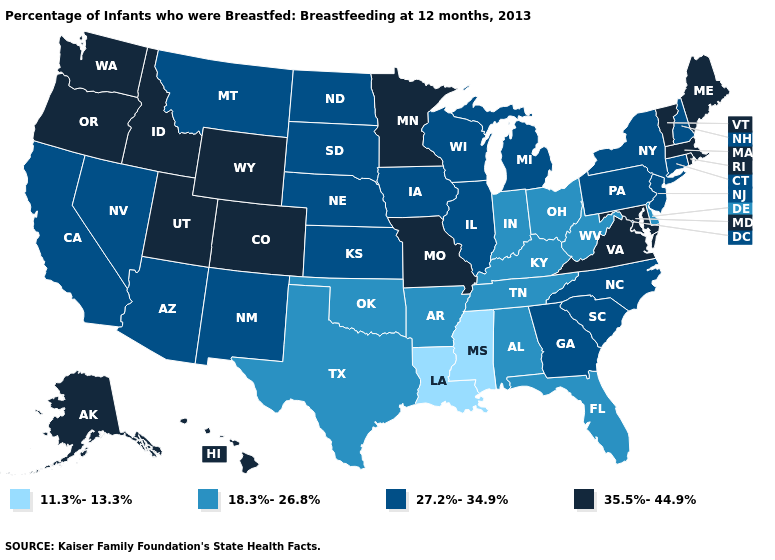What is the lowest value in the West?
Give a very brief answer. 27.2%-34.9%. Name the states that have a value in the range 35.5%-44.9%?
Quick response, please. Alaska, Colorado, Hawaii, Idaho, Maine, Maryland, Massachusetts, Minnesota, Missouri, Oregon, Rhode Island, Utah, Vermont, Virginia, Washington, Wyoming. Does Wisconsin have the lowest value in the MidWest?
Write a very short answer. No. Does Louisiana have the same value as Mississippi?
Write a very short answer. Yes. What is the value of Connecticut?
Give a very brief answer. 27.2%-34.9%. What is the value of Colorado?
Quick response, please. 35.5%-44.9%. What is the value of Utah?
Be succinct. 35.5%-44.9%. Among the states that border Alabama , which have the lowest value?
Short answer required. Mississippi. Name the states that have a value in the range 11.3%-13.3%?
Write a very short answer. Louisiana, Mississippi. Name the states that have a value in the range 27.2%-34.9%?
Be succinct. Arizona, California, Connecticut, Georgia, Illinois, Iowa, Kansas, Michigan, Montana, Nebraska, Nevada, New Hampshire, New Jersey, New Mexico, New York, North Carolina, North Dakota, Pennsylvania, South Carolina, South Dakota, Wisconsin. What is the lowest value in states that border Nevada?
Quick response, please. 27.2%-34.9%. What is the lowest value in the West?
Give a very brief answer. 27.2%-34.9%. What is the value of Connecticut?
Write a very short answer. 27.2%-34.9%. Among the states that border Nevada , does Oregon have the lowest value?
Be succinct. No. 